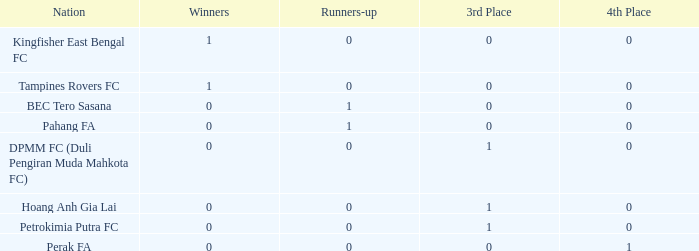Name the average 3rd place with winners of 0, 4th place of 0 and nation of pahang fa 0.0. 